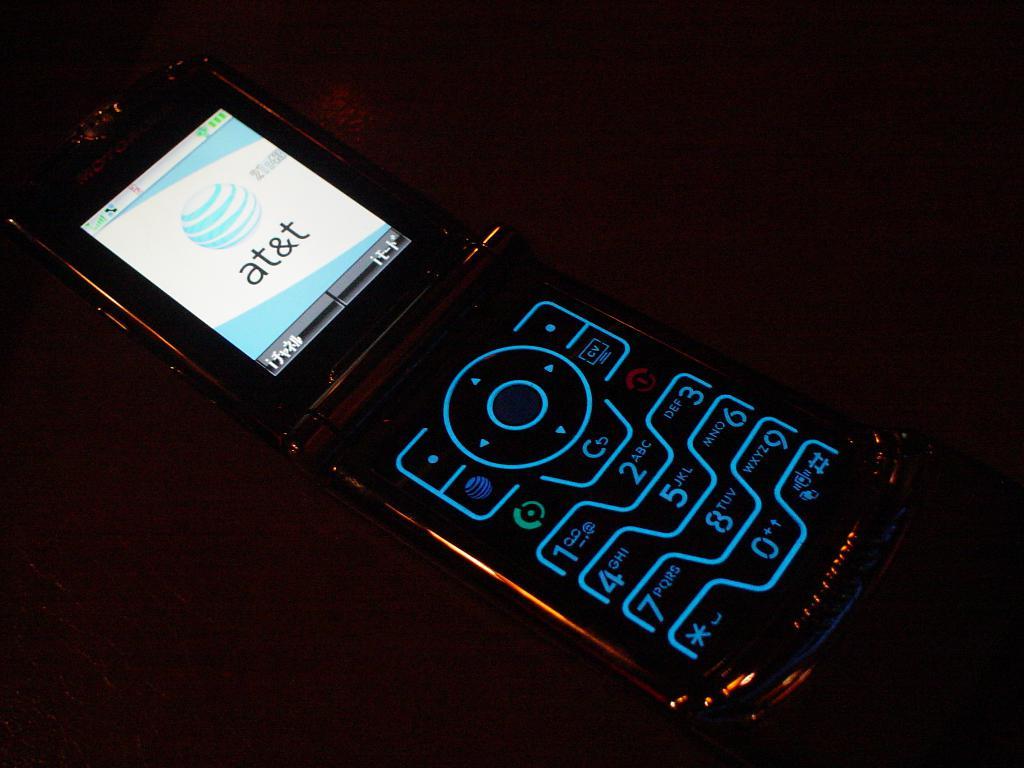What cellular carrier does this phone use?
Ensure brevity in your answer.  At&t. What time is on the phone?
Provide a succinct answer. Unanswerable. 